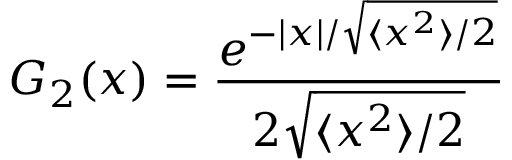<formula> <loc_0><loc_0><loc_500><loc_500>G _ { 2 } ( x ) = \frac { e ^ { - | x | / \sqrt { \langle x ^ { 2 } \rangle / 2 } } } { 2 \sqrt { \langle x ^ { 2 } \rangle / 2 } }</formula> 